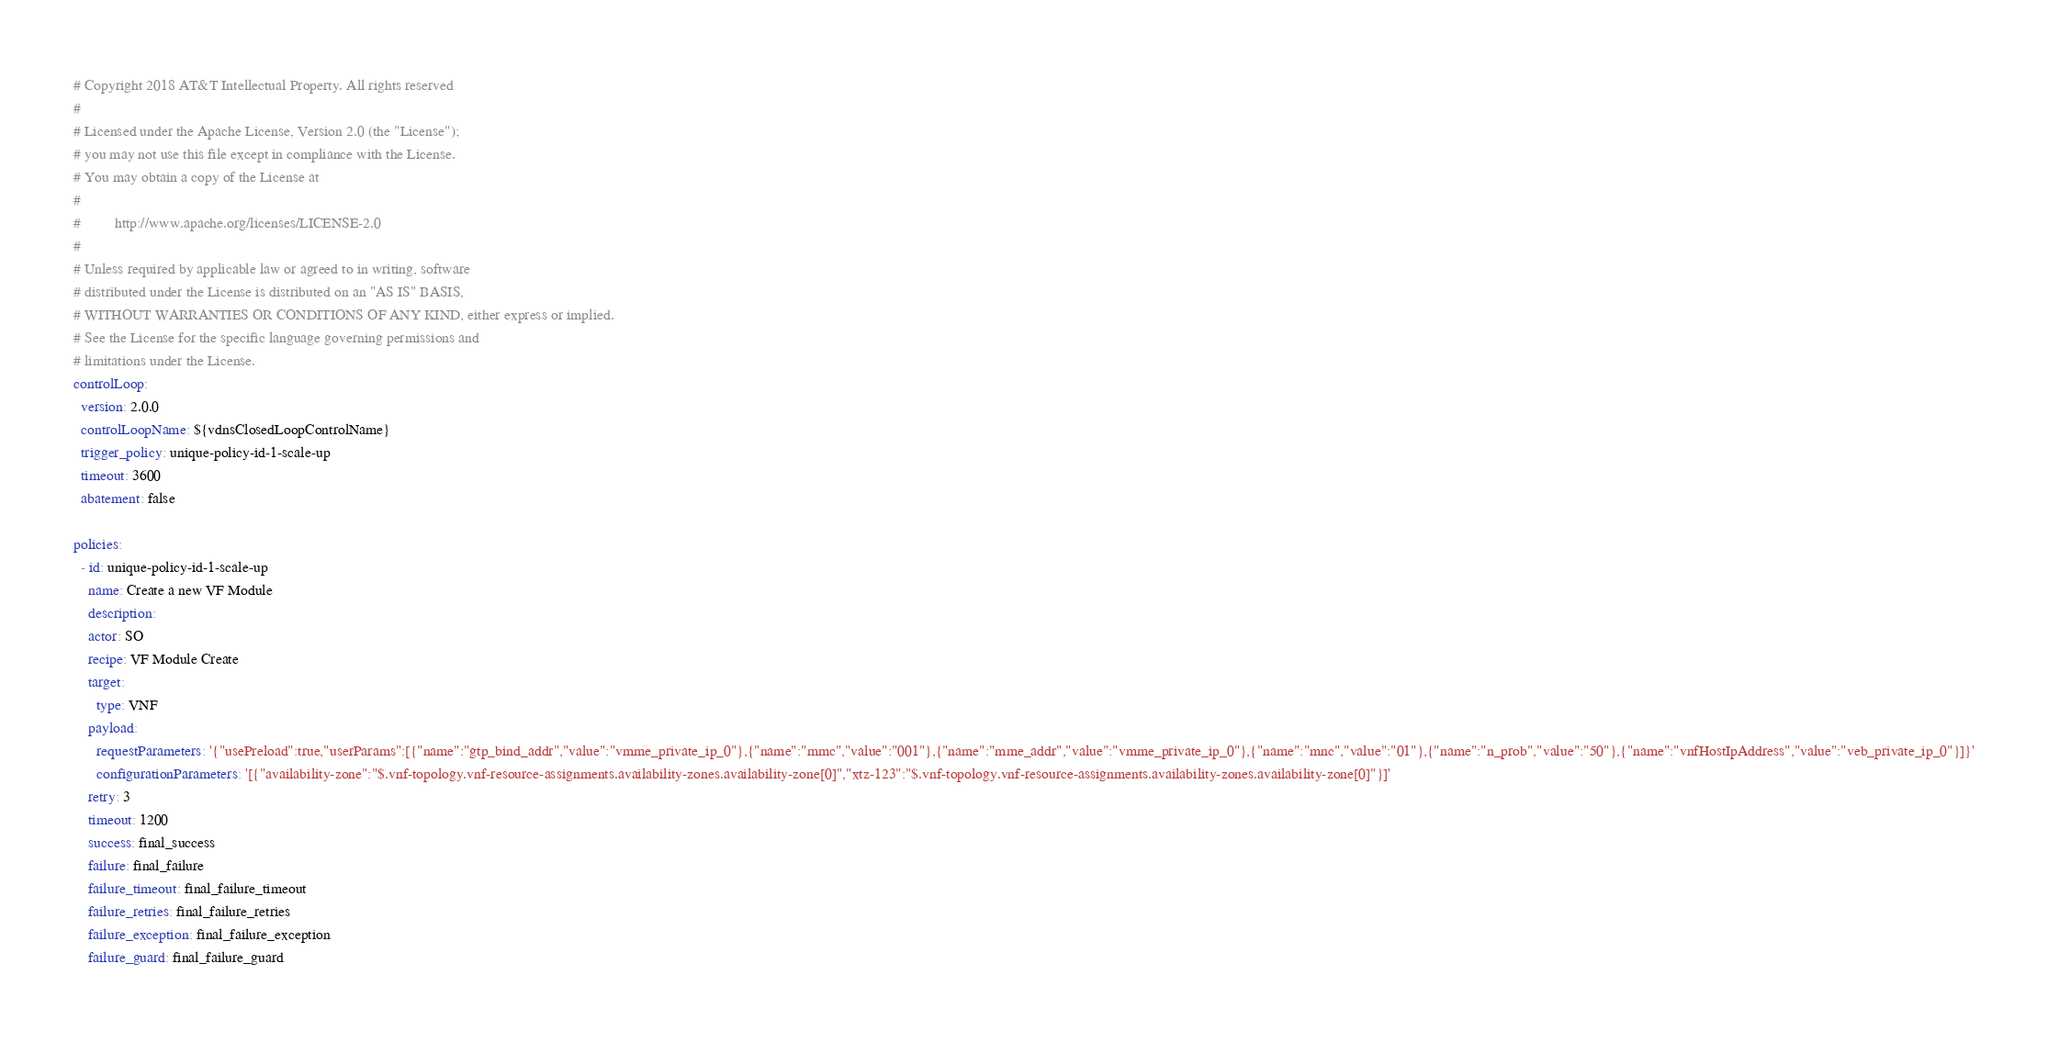<code> <loc_0><loc_0><loc_500><loc_500><_YAML_># Copyright 2018 AT&T Intellectual Property. All rights reserved
#
# Licensed under the Apache License, Version 2.0 (the "License");
# you may not use this file except in compliance with the License.
# You may obtain a copy of the License at
#
#         http://www.apache.org/licenses/LICENSE-2.0
#
# Unless required by applicable law or agreed to in writing, software
# distributed under the License is distributed on an "AS IS" BASIS,
# WITHOUT WARRANTIES OR CONDITIONS OF ANY KIND, either express or implied.
# See the License for the specific language governing permissions and
# limitations under the License.
controlLoop:
  version: 2.0.0
  controlLoopName: ${vdnsClosedLoopControlName}
  trigger_policy: unique-policy-id-1-scale-up
  timeout: 3600
  abatement: false
 
policies:
  - id: unique-policy-id-1-scale-up
    name: Create a new VF Module
    description:
    actor: SO
    recipe: VF Module Create
    target:
      type: VNF
    payload:
      requestParameters: '{"usePreload":true,"userParams":[{"name":"gtp_bind_addr","value":"vmme_private_ip_0"},{"name":"mmc","value":"001"},{"name":"mme_addr","value":"vmme_private_ip_0"},{"name":"mnc","value":"01"},{"name":"n_prob","value":"50"},{"name":"vnfHostIpAddress","value":"veb_private_ip_0"}]}'
      configurationParameters: '[{"availability-zone":"$.vnf-topology.vnf-resource-assignments.availability-zones.availability-zone[0]","xtz-123":"$.vnf-topology.vnf-resource-assignments.availability-zones.availability-zone[0]"}]'
    retry: 3
    timeout: 1200
    success: final_success
    failure: final_failure
    failure_timeout: final_failure_timeout
    failure_retries: final_failure_retries
    failure_exception: final_failure_exception
    failure_guard: final_failure_guard
</code> 